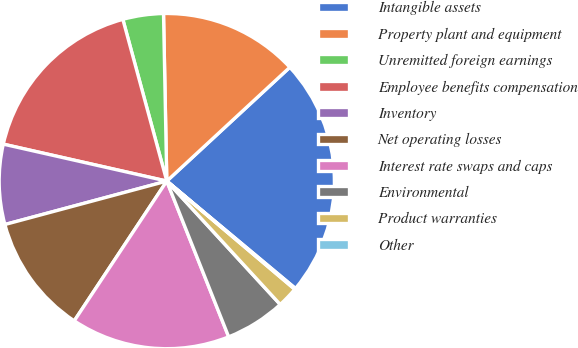Convert chart to OTSL. <chart><loc_0><loc_0><loc_500><loc_500><pie_chart><fcel>Intangible assets<fcel>Property plant and equipment<fcel>Unremitted foreign earnings<fcel>Employee benefits compensation<fcel>Inventory<fcel>Net operating losses<fcel>Interest rate swaps and caps<fcel>Environmental<fcel>Product warranties<fcel>Other<nl><fcel>22.95%<fcel>13.43%<fcel>3.91%<fcel>17.24%<fcel>7.71%<fcel>11.52%<fcel>15.33%<fcel>5.81%<fcel>2.0%<fcel>0.1%<nl></chart> 